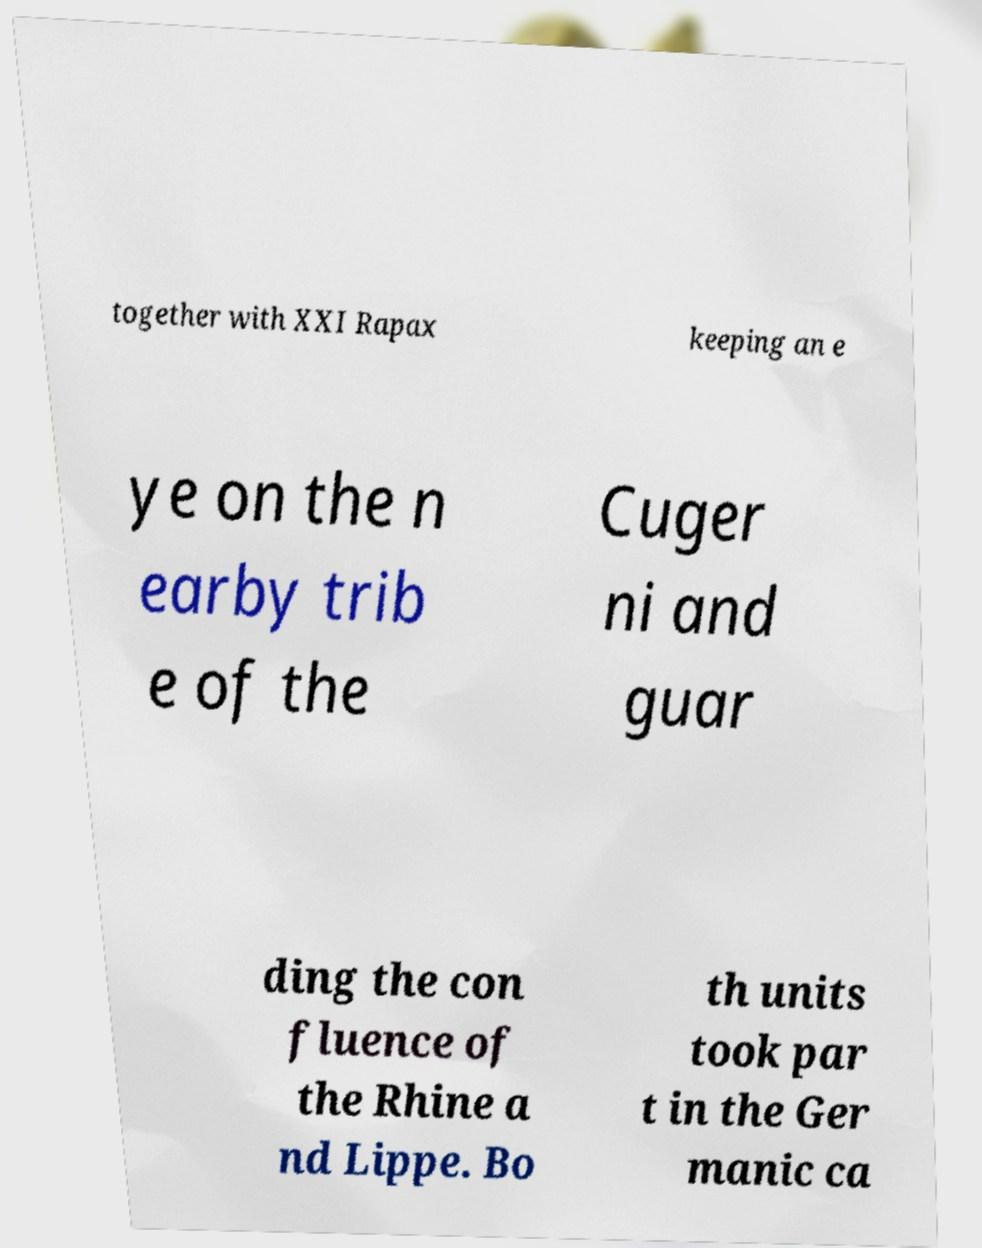Please identify and transcribe the text found in this image. together with XXI Rapax keeping an e ye on the n earby trib e of the Cuger ni and guar ding the con fluence of the Rhine a nd Lippe. Bo th units took par t in the Ger manic ca 